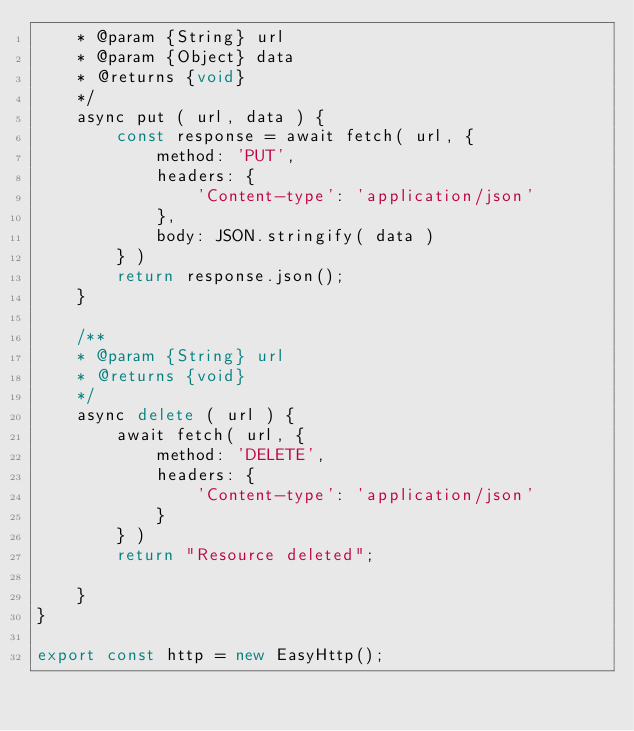Convert code to text. <code><loc_0><loc_0><loc_500><loc_500><_JavaScript_>    * @param {String} url
    * @param {Object} data
    * @returns {void}
    */
    async put ( url, data ) {
        const response = await fetch( url, {
            method: 'PUT',
            headers: {
                'Content-type': 'application/json'
            },
            body: JSON.stringify( data )
        } )
        return response.json();
    }

    /**
    * @param {String} url
    * @returns {void}
    */
    async delete ( url ) {
        await fetch( url, {
            method: 'DELETE',
            headers: {
                'Content-type': 'application/json'
            }
        } )
        return "Resource deleted";

    }
}

export const http = new EasyHttp();</code> 